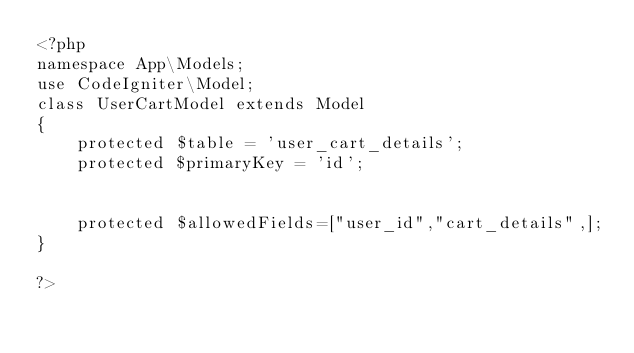<code> <loc_0><loc_0><loc_500><loc_500><_PHP_><?php 
namespace App\Models;
use CodeIgniter\Model;
class UserCartModel extends Model
{
    protected $table = 'user_cart_details';
    protected $primaryKey = 'id';


    protected $allowedFields=["user_id","cart_details",];
}

?></code> 